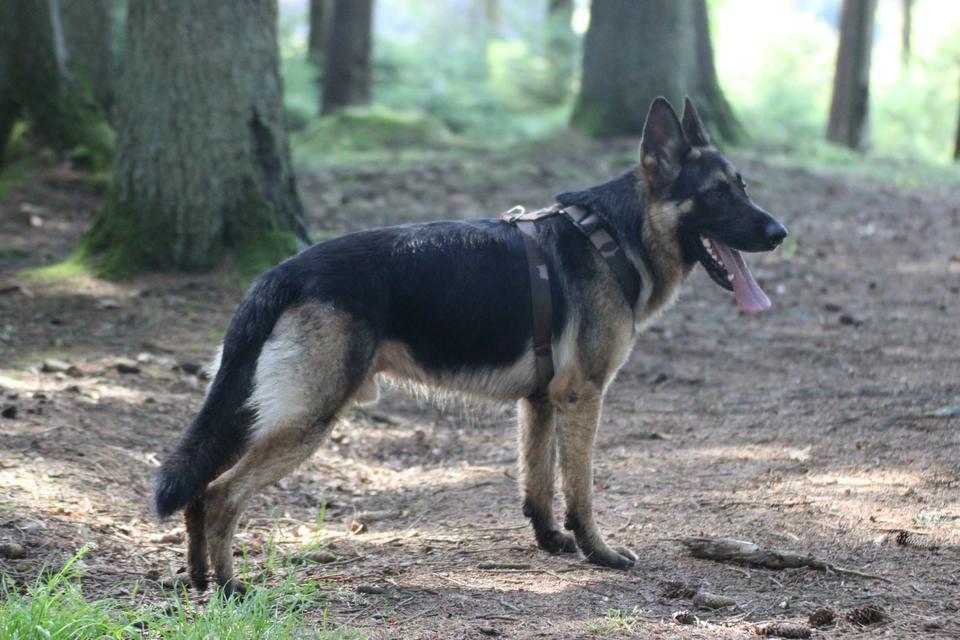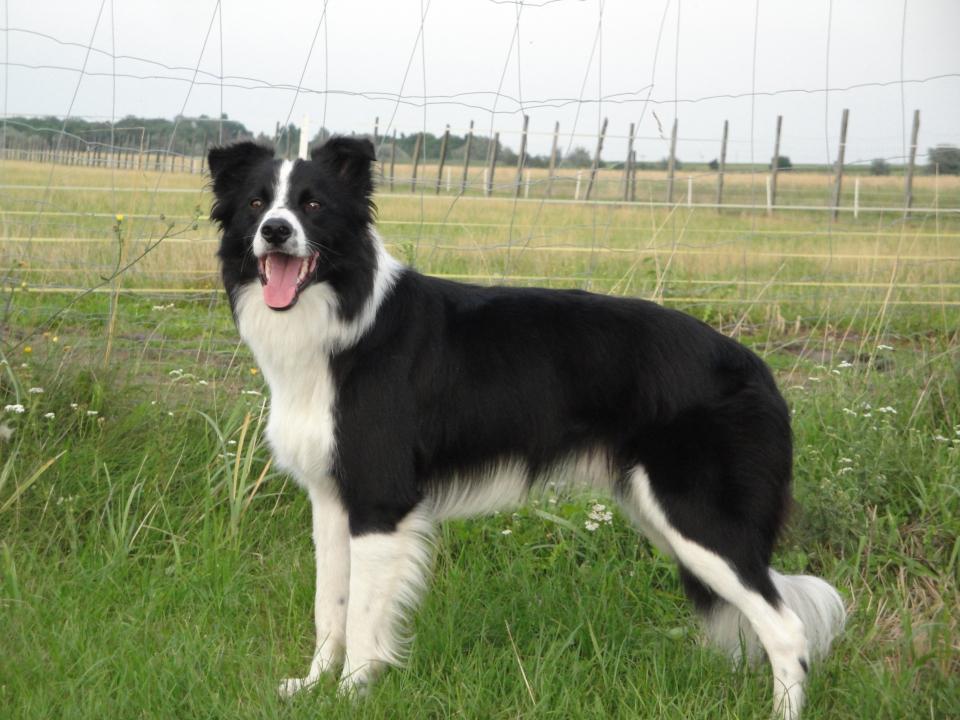The first image is the image on the left, the second image is the image on the right. Given the left and right images, does the statement "One image contains four or more dogs that are grouped together in a pose." hold true? Answer yes or no. No. The first image is the image on the left, the second image is the image on the right. Considering the images on both sides, is "Some of the dogs are sitting down." valid? Answer yes or no. No. 